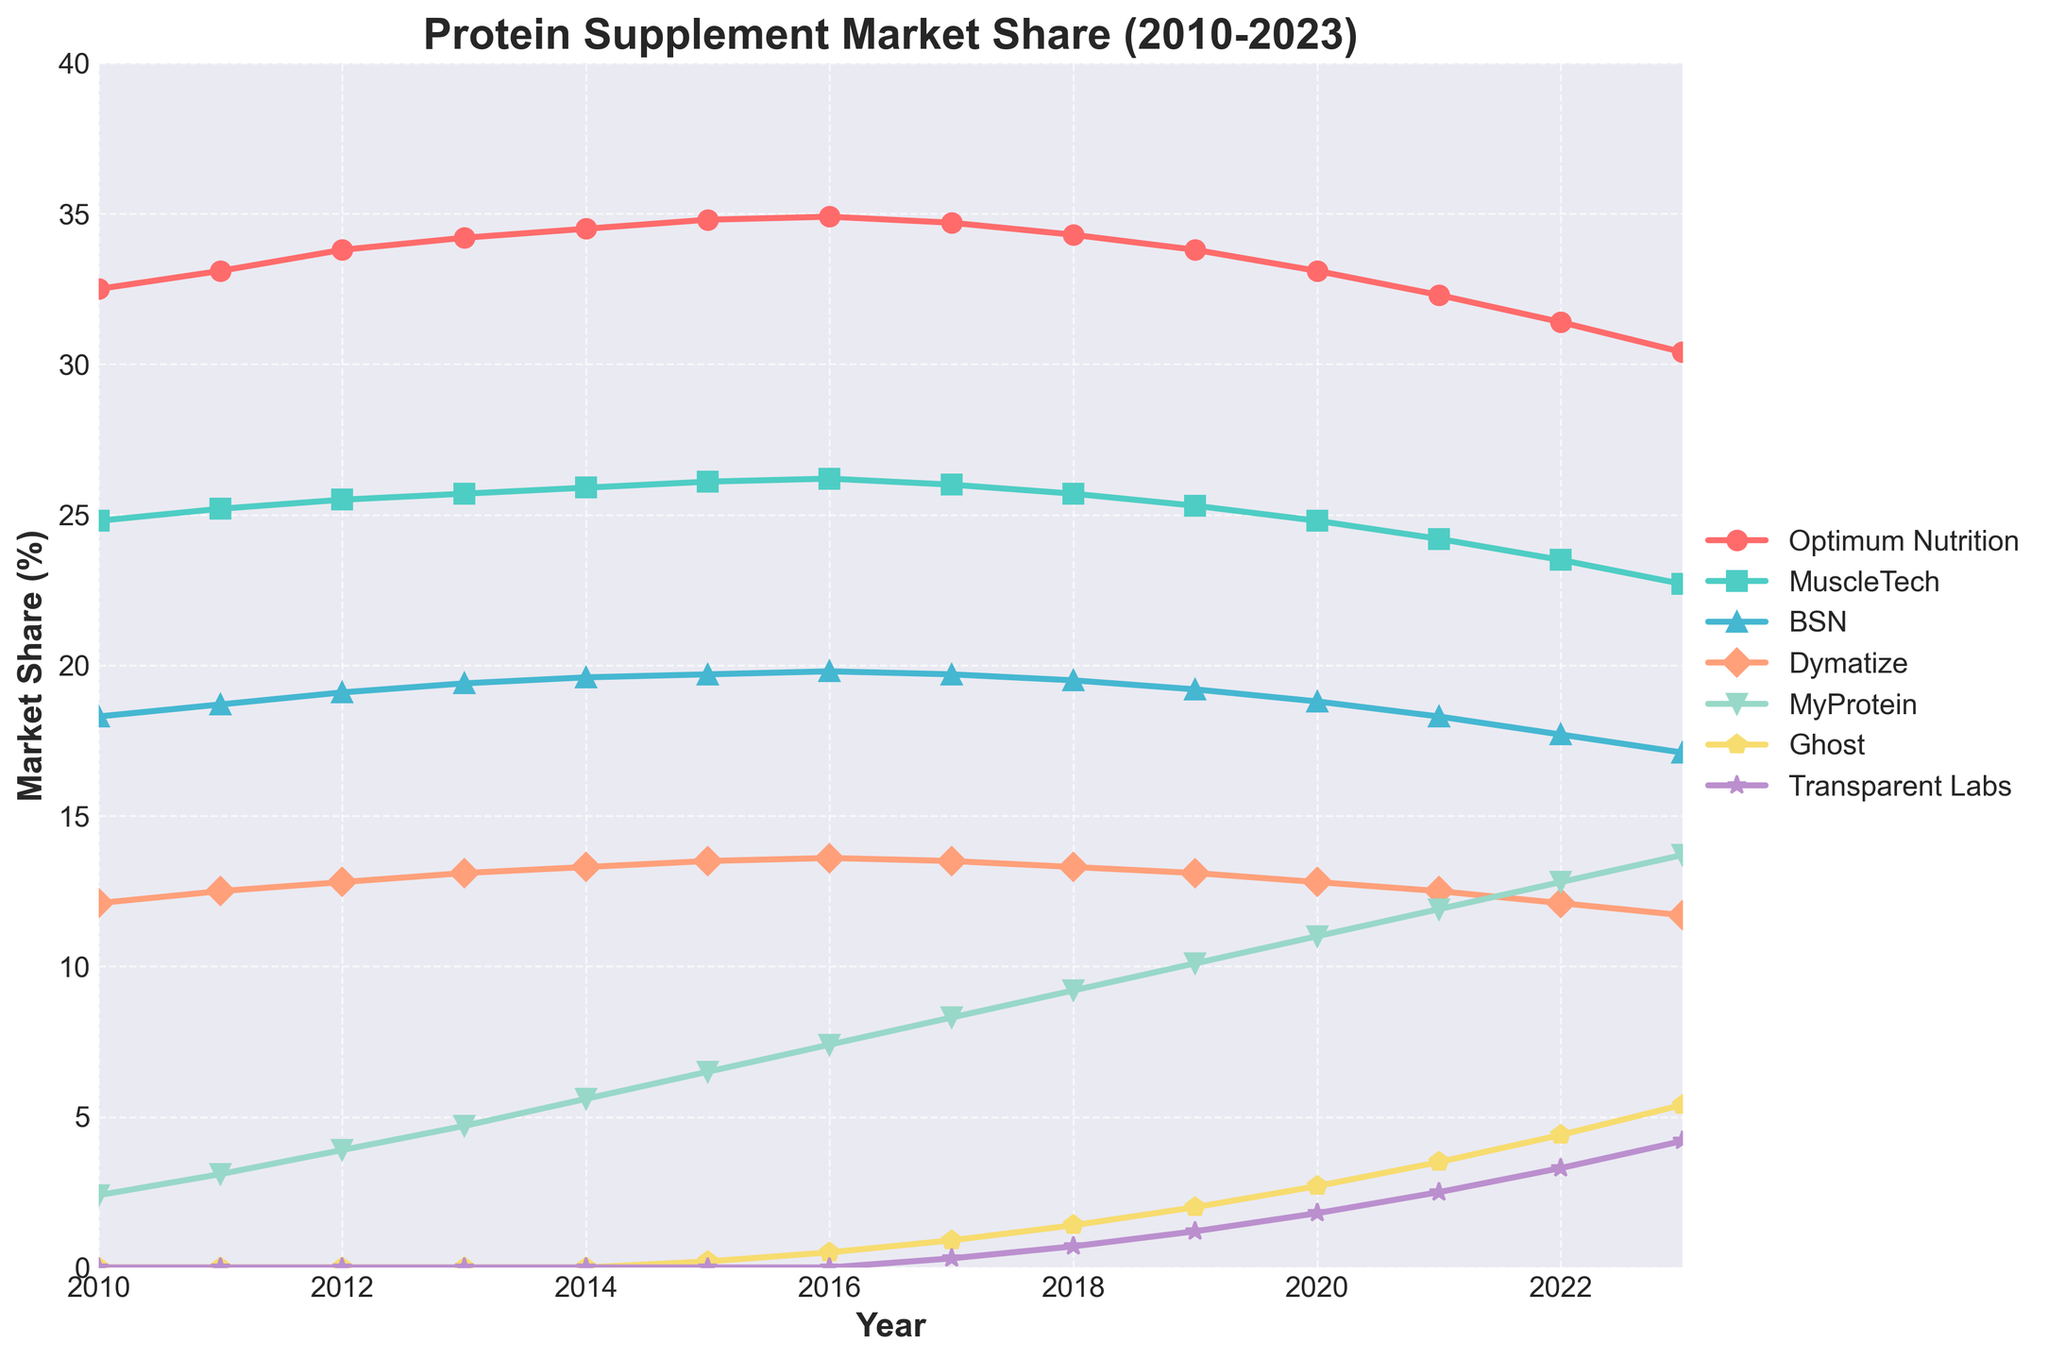What was the market share of Optimum Nutrition in 2010 and how did it change by 2023? To find the market share of Optimum Nutrition in 2010, look at the corresponding value in the dataset for that year which is 32.5%. By 2023, this value had decreased to 30.4%. The change can be calculated as 32.5% - 30.4% = 2.1%.
Answer: Optimum Nutrition's market share decreased by 2.1% Which brand had the highest market share in 2023? In 2023, examining all the market shares, Optimum Nutrition holds the highest share at 30.4%.
Answer: Optimum Nutrition By how much did MyProtein's market share increase from 2010 to 2023? According to the data, MyProtein's market share was 2.4% in 2010 and increased to 13.7% in 2023. The amount of increase is calculated by 13.7% - 2.4% = 11.3%.
Answer: 11.3% Did Dymatize's market share increase or decrease from 2010 to 2023? In 2010, Dymatize's market share was 12.1% and by 2023 it was 11.7%. This shows a decrease.
Answer: Decrease Between which consecutive years did Ghost experience the highest growth in market share? To determine the highest growth, look at Ghost's values for each consecutive year. The largest increase was from 2021 (3.5%) to 2022 (4.4%), calculated as 4.4% - 3.5% = 0.9%.
Answer: Between 2021 and 2022 What was the combined market share of MuscleTech and BSN in 2015? In 2015, MuscleTech had a market share of 26.1% and BSN had 19.7%. Adding them gives 26.1% + 19.7% = 45.8%.
Answer: 45.8% Which emerging competitor had the fastest growth from its introduction to 2023? By examining the data, Ghost was introduced in 2015 with 0.2% and reached 5.4% by 2023. The increase is calculated as 5.4% - 0.2% = 5.2%. Transparent Labs was introduced in 2017 and grew to 4.2% by 2023, an increase of 4.2% - 0.3% = 3.9%. Therefore, Ghost had faster growth.
Answer: Ghost How did the market share trend of BSN compare to that of MyProtein from 2010 to 2023? BSN's market share decreased from 18.3% in 2010 to 17.1% in 2023. In contrast, MyProtein's market share increased from 2.4% to 13.7% over the same period. This comparison indicates BSN had a downward trend while MyProtein had a significant upward trend.
Answer: BSN decreased, MyProtein increased What is the difference in market share between the highest and the lowest brands in 2023? In 2023, the highest market share was held by Optimum Nutrition at 30.4%, and the lowest among listed brands was Dymatize at 11.7%. The difference is 30.4% - 11.7% = 18.7%.
Answer: 18.7% Which brand showed a consistent increase in market share every year from 2010 to 2023? By checking each year's values, MyProtein consistently increased its market share every year from 2010 (2.4%) to 2023 (13.7%).
Answer: MyProtein 